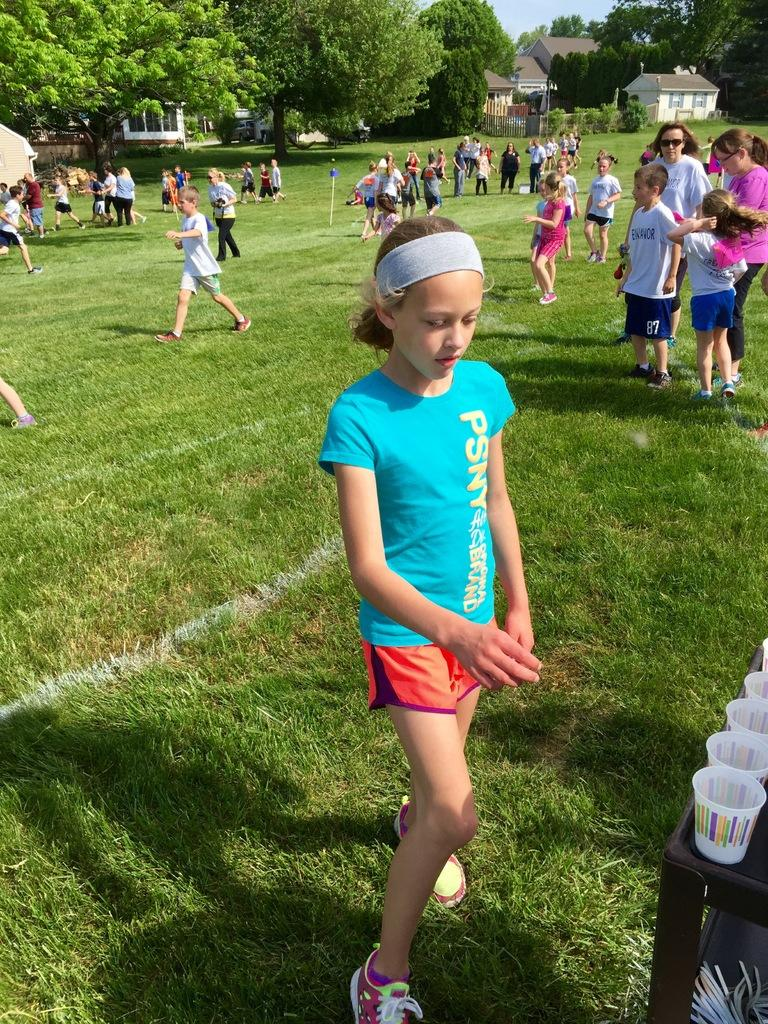What are the people in the image doing? The people in the image are walking on the land. Can you describe the age group of some individuals in the image? Yes, there are children in the image. What can be seen in the background of the image? There are trees and houses in the background of the image. What type of sign can be seen in the image? There is no sign present in the image. Can you describe the taste of the trees in the background? Trees do not have a taste, as they are not edible. 